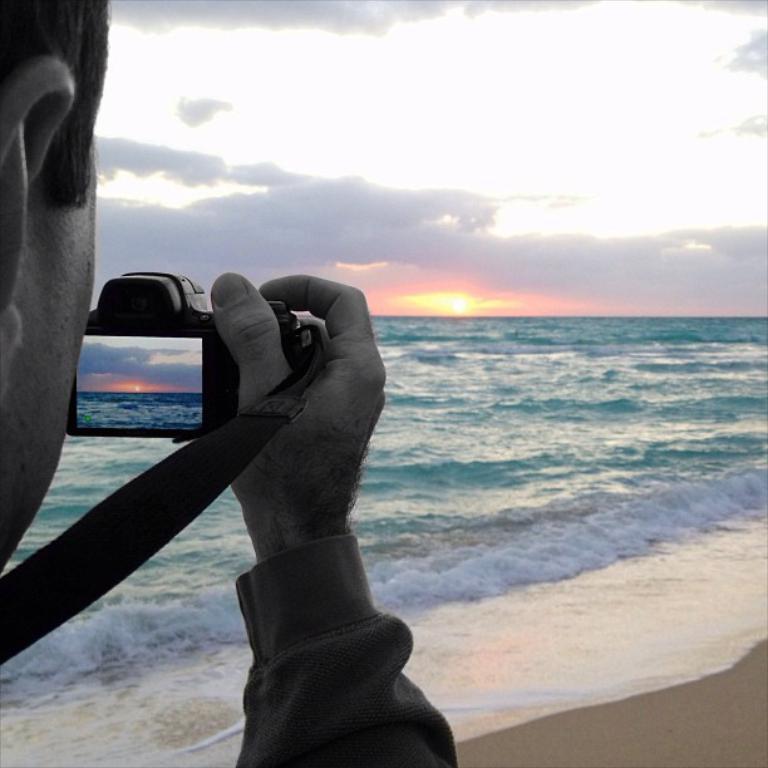In one or two sentences, can you explain what this image depicts? In this image I can see the person holding the camera. In the background I can see the water in green color. I can also see the sun, clouds and the sky in the back. 